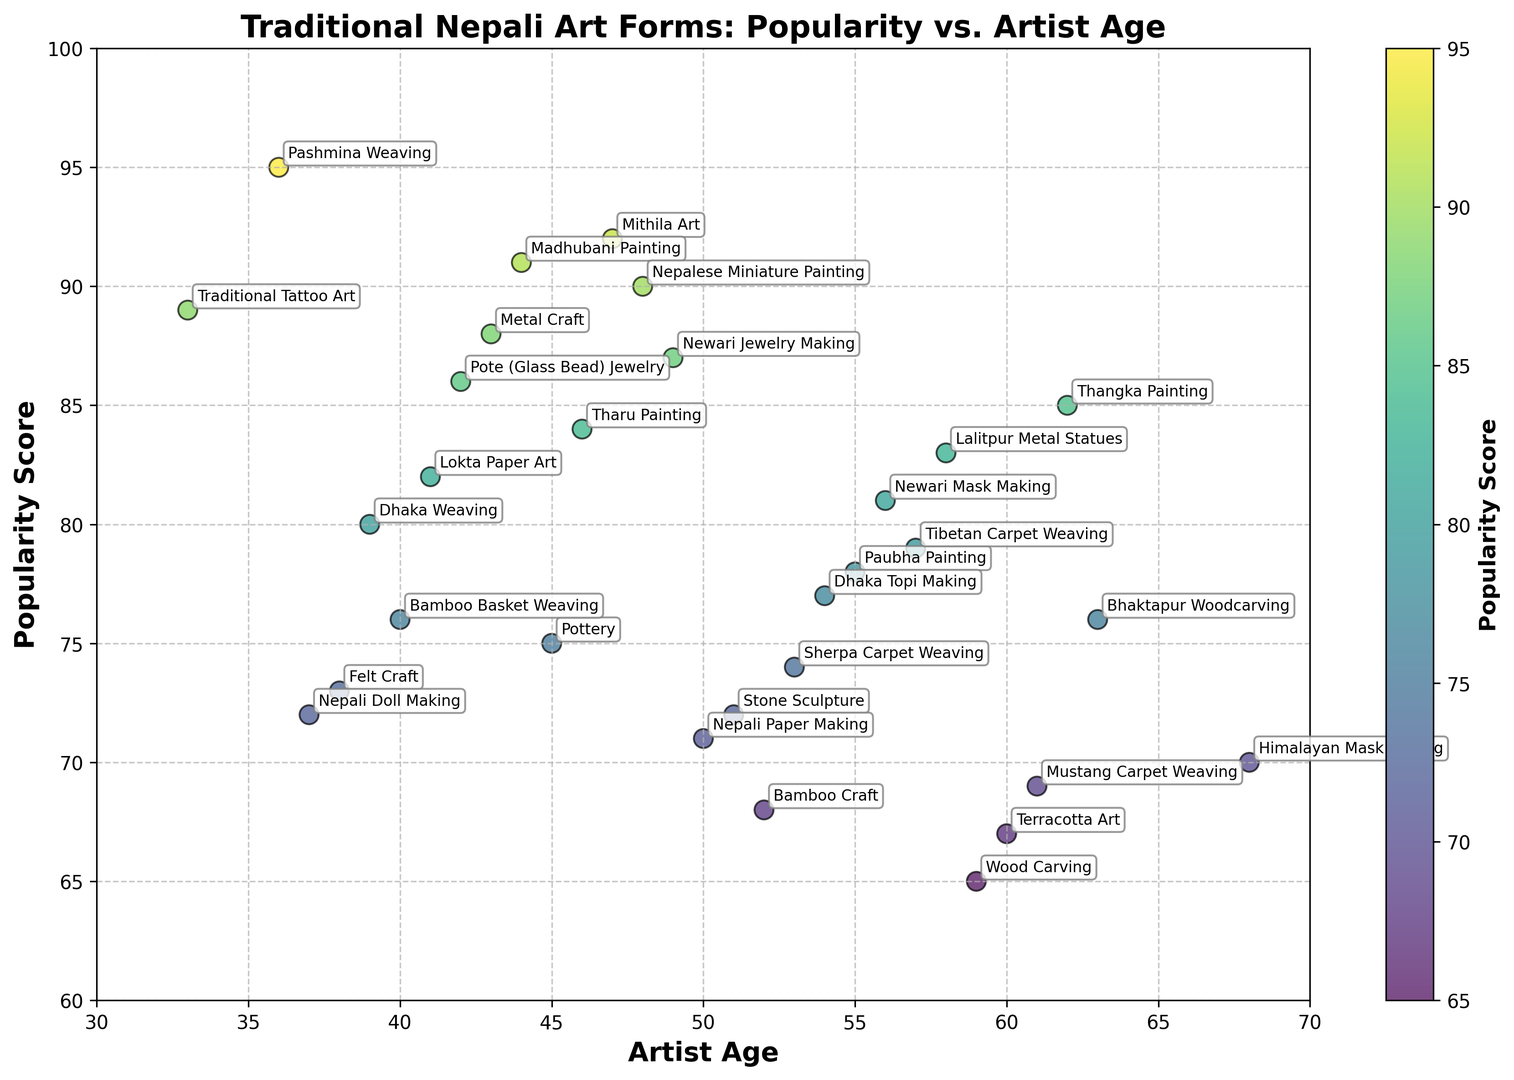Which art form has the highest popularity score and what is its value? To find the art form with the highest popularity score, you need to look for the data point with the maximum value on the y-axis. According to the figure, "Pashmina Weaving" has the highest popularity score, which is 95.
Answer: Pashmina Weaving, 95 How does the popularity of Thangka Painting compare to Mithila Art? Check the y-axis values corresponding to "Thangka Painting" and "Mithila Art". Thangka Painting has a score of 85, while Mithila Art has a score of 92. Therefore, Mithila Art is more popular than Thangka Painting.
Answer: Mithila Art is more popular What is the average age of artists for Metal Craft, Dhaka Weaving, and Traditional Tattoo Art? First, note the artist ages: Metal Craft (43), Dhaka Weaving (39), Traditional Tattoo Art (33). Calculate the average by adding these ages and dividing by the number of art forms: (43 + 39 + 33) / 3 = 38.33.
Answer: 38.33 What is the difference in popularity score between Paubha Painting and Dhaka Topi Making? Examine the y-axis values: Paubha Painting has a popularity score of 78, and Dhaka Topi Making has a score of 77. Subtract the lesser from the greater score to find the difference: 78 - 77 = 1.
Answer: 1 Based on the figure, which art form has the oldest artist age and what is that age? Scan for the maximum x-axis value to determine the oldest artist age. The highest age is 68, which corresponds to Himalayan Mask Making.
Answer: Himalayan Mask Making, 68 What is the minimum popularity score for art forms where the artist's age is below 40? Identify the art forms where artist ages are below 40: Dhaka Weaving (39), Pashmina Weaving (36), Traditional Tattoo Art (33), Felt Craft (38), Nepali Doll Making (37). The corresponding popularity scores are 80, 95, 89, 73, and 72. The minimum score among these is 72 for Nepali Doll Making.
Answer: 72 Which art forms are equally popular and what is their popularity score? Locate art forms sharing the same y-axis value. "Lalitpur Metal Statues" and "Lokta Paper Art" both have a popularity score of 82.
Answer: Lalitpur Metal Statues and Lokta Paper Art, 82 What is the median popularity score of all the art forms? List all the popularity scores in ascending order and find the middle value(s): 65, 67, 68, 69, 70, 71, 72, 72, 73, 74, 75, 76, 76, 77, 78, 79, 80, 81, 82, 83, 84, 85, 86, 87, 88, 89, 90, 91, 92, 95. With 30 values, the median is the average of the 15th and 16th values: (76+78)/2 = 77.
Answer: 77 